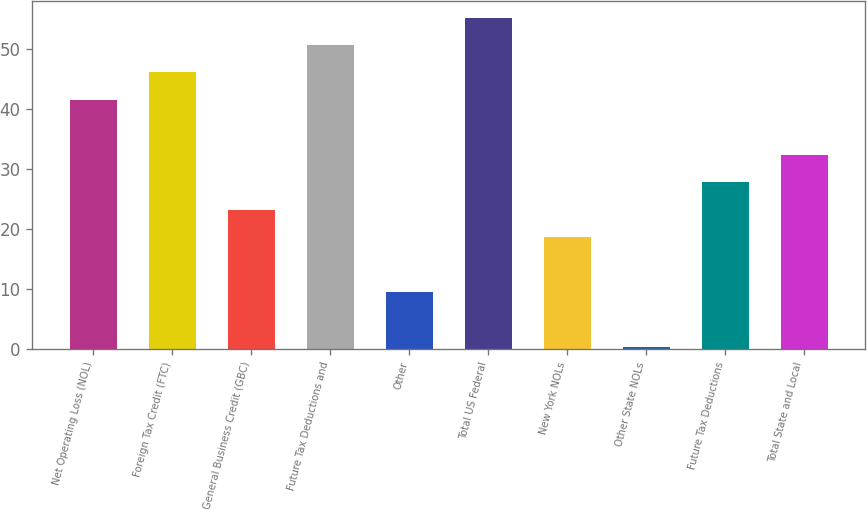Convert chart to OTSL. <chart><loc_0><loc_0><loc_500><loc_500><bar_chart><fcel>Net Operating Loss (NOL)<fcel>Foreign Tax Credit (FTC)<fcel>General Business Credit (GBC)<fcel>Future Tax Deductions and<fcel>Other<fcel>Total US Federal<fcel>New York NOLs<fcel>Other State NOLs<fcel>Future Tax Deductions<fcel>Total State and Local<nl><fcel>41.53<fcel>46.1<fcel>23.25<fcel>50.67<fcel>9.54<fcel>55.24<fcel>18.68<fcel>0.4<fcel>27.82<fcel>32.39<nl></chart> 